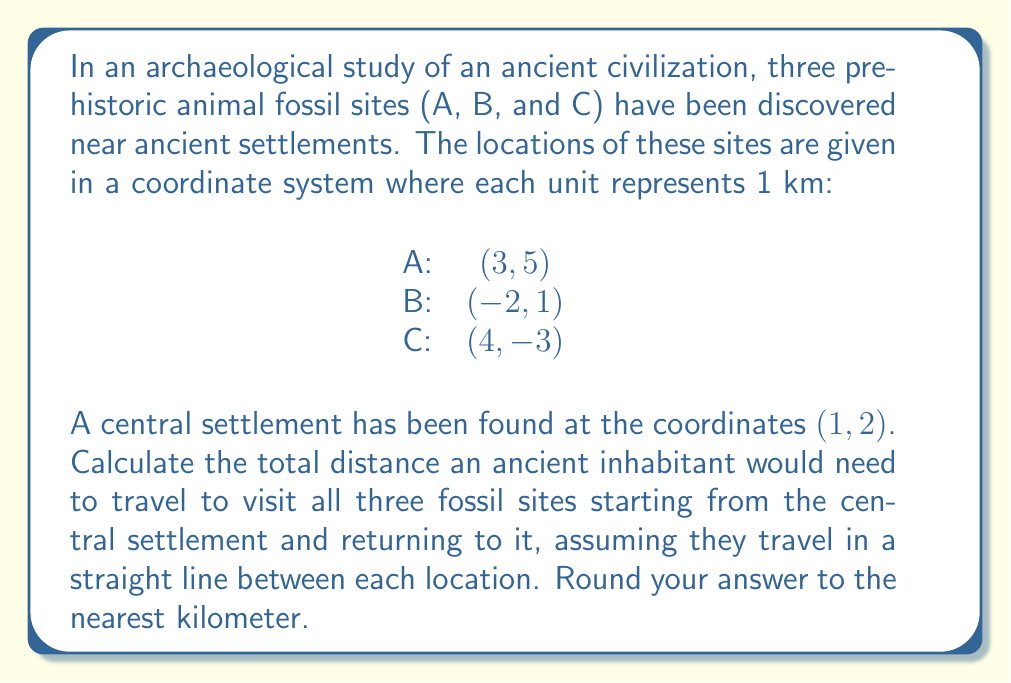Teach me how to tackle this problem. To solve this problem, we need to calculate the distances between each pair of points and sum them up. We'll use the distance formula between two points $(x_1, y_1)$ and $(x_2, y_2)$:

$$ d = \sqrt{(x_2 - x_1)^2 + (y_2 - y_1)^2} $$

Let's calculate each distance:

1. Central settlement (1, 2) to Site A (3, 5):
   $$ d_1 = \sqrt{(3-1)^2 + (5-2)^2} = \sqrt{4 + 9} = \sqrt{13} \approx 3.61 \text{ km} $$

2. Site A (3, 5) to Site B (-2, 1):
   $$ d_2 = \sqrt{(-2-3)^2 + (1-5)^2} = \sqrt{25 + 16} = \sqrt{41} \approx 6.40 \text{ km} $$

3. Site B (-2, 1) to Site C (4, -3):
   $$ d_3 = \sqrt{(4-(-2))^2 + (-3-1)^2} = \sqrt{36 + 16} = \sqrt{52} \approx 7.21 \text{ km} $$

4. Site C (4, -3) back to Central settlement (1, 2):
   $$ d_4 = \sqrt{(1-4)^2 + (2-(-3))^2} = \sqrt{9 + 25} = \sqrt{34} \approx 5.83 \text{ km} $$

Now, we sum up all these distances:

$$ \text{Total distance} = d_1 + d_2 + d_3 + d_4 $$
$$ \approx 3.61 + 6.40 + 7.21 + 5.83 = 23.05 \text{ km} $$

Rounding to the nearest kilometer, we get 23 km.
Answer: 23 km 